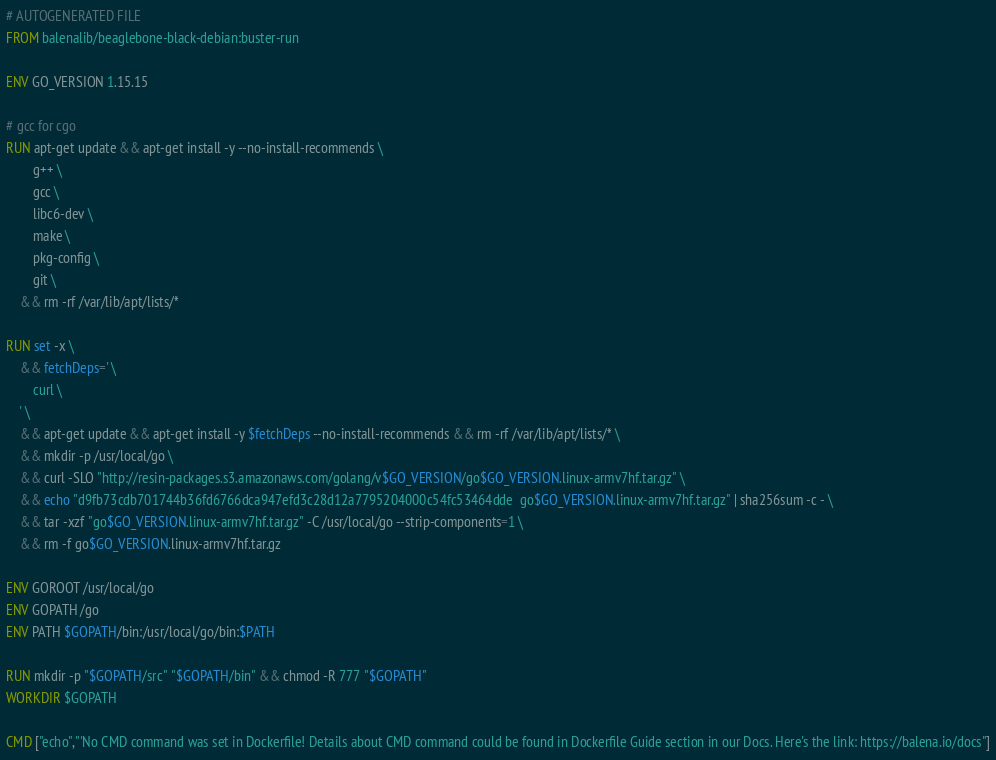Convert code to text. <code><loc_0><loc_0><loc_500><loc_500><_Dockerfile_># AUTOGENERATED FILE
FROM balenalib/beaglebone-black-debian:buster-run

ENV GO_VERSION 1.15.15

# gcc for cgo
RUN apt-get update && apt-get install -y --no-install-recommends \
		g++ \
		gcc \
		libc6-dev \
		make \
		pkg-config \
		git \
	&& rm -rf /var/lib/apt/lists/*

RUN set -x \
	&& fetchDeps=' \
		curl \
	' \
	&& apt-get update && apt-get install -y $fetchDeps --no-install-recommends && rm -rf /var/lib/apt/lists/* \
	&& mkdir -p /usr/local/go \
	&& curl -SLO "http://resin-packages.s3.amazonaws.com/golang/v$GO_VERSION/go$GO_VERSION.linux-armv7hf.tar.gz" \
	&& echo "d9fb73cdb701744b36fd6766dca947efd3c28d12a7795204000c54fc53464dde  go$GO_VERSION.linux-armv7hf.tar.gz" | sha256sum -c - \
	&& tar -xzf "go$GO_VERSION.linux-armv7hf.tar.gz" -C /usr/local/go --strip-components=1 \
	&& rm -f go$GO_VERSION.linux-armv7hf.tar.gz

ENV GOROOT /usr/local/go
ENV GOPATH /go
ENV PATH $GOPATH/bin:/usr/local/go/bin:$PATH

RUN mkdir -p "$GOPATH/src" "$GOPATH/bin" && chmod -R 777 "$GOPATH"
WORKDIR $GOPATH

CMD ["echo","'No CMD command was set in Dockerfile! Details about CMD command could be found in Dockerfile Guide section in our Docs. Here's the link: https://balena.io/docs"]
</code> 